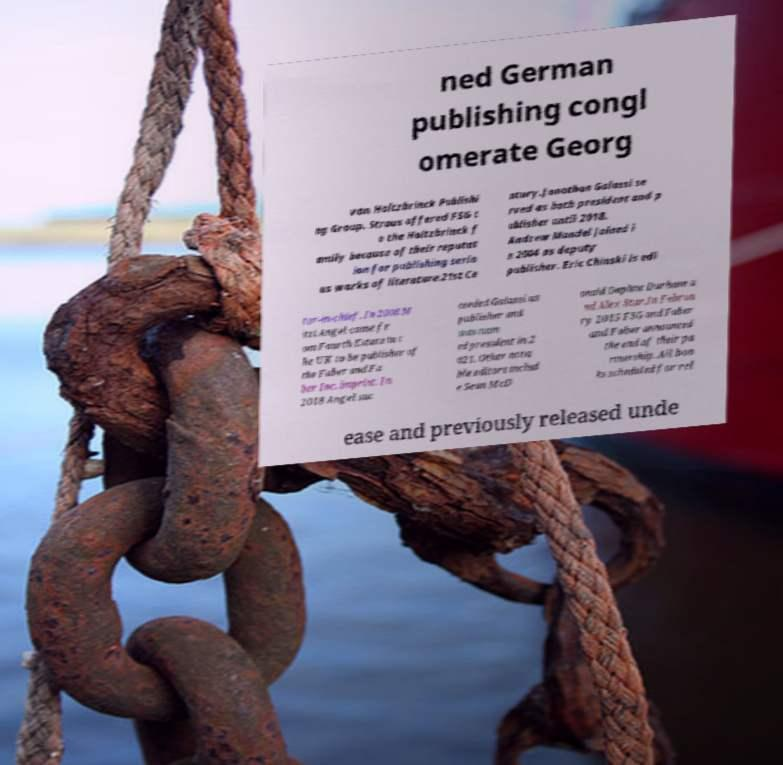Can you accurately transcribe the text from the provided image for me? ned German publishing congl omerate Georg von Holtzbrinck Publishi ng Group. Straus offered FSG t o the Holtzbrinck f amily because of their reputat ion for publishing serio us works of literature.21st Ce ntury.Jonathan Galassi se rved as both president and p ublisher until 2018. Andrew Mandel joined i n 2004 as deputy publisher. Eric Chinski is edi tor-in-chief. In 2008 M itzi Angel came fr om Fourth Estate in t he UK to be publisher of the Faber and Fa ber Inc. imprint. In 2018 Angel suc ceeded Galassi as publisher and was nam ed president in 2 021. Other nota ble editors includ e Sean McD onald Daphne Durham a nd Alex Star.In Februa ry 2015 FSG and Faber and Faber announced the end of their pa rtnership. All boo ks scheduled for rel ease and previously released unde 